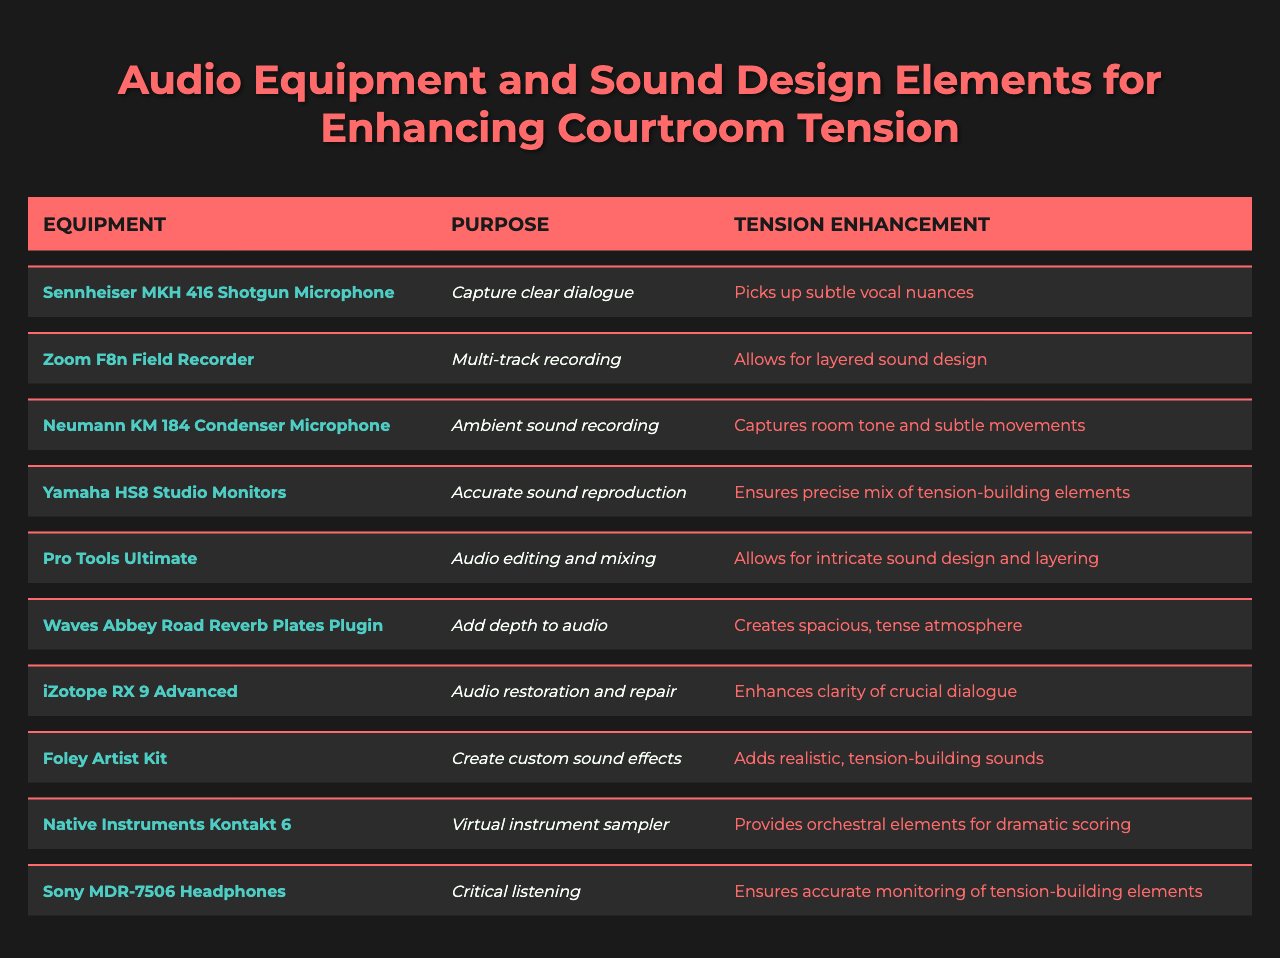What is the purpose of the Sennheiser MKH 416 Shotgun Microphone? The table states that the purpose of the Sennheiser MKH 416 Shotgun Microphone is to "capture clear dialogue."
Answer: Capture clear dialogue How does the Zoom F8n Field Recorder enhance tension? According to the table, the Zoom F8n Field Recorder enhances tension by allowing for "layered sound design."
Answer: Allows for layered sound design Is the Neumann KM 184 Condenser Microphone used for dialogue recording? The table specifies that the purpose of the Neumann KM 184 is "ambient sound recording," not directly for dialogue.
Answer: No Which equipment is mentioned as used for audio restoration? The table lists the iZotope RX 9 Advanced as the equipment used for audio restoration.
Answer: iZotope RX 9 Advanced What equipment provides orchestral elements for dramatic scoring? The table indicates that Native Instruments Kontakt 6 provides orchestral elements for dramatic scoring.
Answer: Native Instruments Kontakt 6 How many pieces of equipment listed are specifically for enhancing clarity? The table indicates that two pieces of equipment enhance clarity: iZotope RX 9 Advanced (for dialogue) and Sennheiser MKH 416 Shotgun Microphone (captures vocal nuances). Therefore, the count is 2.
Answer: 2 Which audio equipment is focused on critical listening? The table shows that the Sony MDR-7506 Headphones are designated for critical listening.
Answer: Sony MDR-7506 Headphones If you combine the purposes of Pro Tools Ultimate and Waves Abbey Road Reverb Plates Plugin, what do you get? The purpose of Pro Tools Ultimate is for audio editing and mixing, and Waves Abbey Road Reverb Plates Plugin adds depth to audio. Together, they facilitate intricate sound design that supports a tense atmosphere.
Answer: Intricate sound design supporting a tense atmosphere Which equipment is responsible for adding realistic, tension-building sounds? The Foley Artist Kit is responsible for creating custom sound effects that build tension as indicated in the table.
Answer: Foley Artist Kit What is the common enhancement aspect shared by Yamaha HS8 Studio Monitors and Sony MDR-7506 Headphones? Both the Yamaha HS8 Studio Monitors and Sony MDR-7506 Headphones are focused on sound accuracy; the former ensures precise mix and the latter ensures accurate monitoring.
Answer: Focus on sound accuracy 